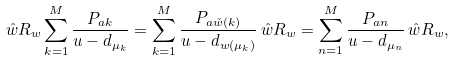<formula> <loc_0><loc_0><loc_500><loc_500>\hat { w } R _ { w } \sum _ { k = 1 } ^ { M } \frac { P _ { a k } } { u - d _ { \mu _ { k } } } = \sum _ { k = 1 } ^ { M } \frac { P _ { a \check { w } ( k ) } } { u - d _ { w ( \mu _ { k } ) } } \, \hat { w } R _ { w } = \sum _ { n = 1 } ^ { M } \frac { P _ { a n } } { u - d _ { \mu _ { n } } } \, \hat { w } R _ { w } ,</formula> 